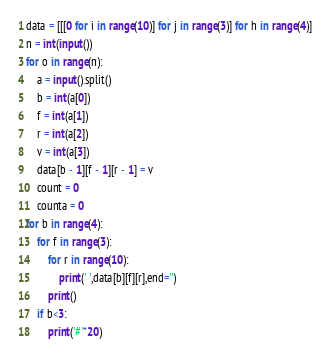Convert code to text. <code><loc_0><loc_0><loc_500><loc_500><_Python_>data = [[[0 for i in range(10)] for j in range(3)] for h in range(4)]
n = int(input())
for o in range(n):
    a = input().split()
    b = int(a[0])
    f = int(a[1])
    r = int(a[2])
    v = int(a[3])
    data[b - 1][f - 1][r - 1] = v
    count = 0
    counta = 0
for b in range(4):
    for f in range(3):
        for r in range(10):
            print(' ',data[b][f][r],end='')
        print()
    if b<3:
        print('#'*20)</code> 